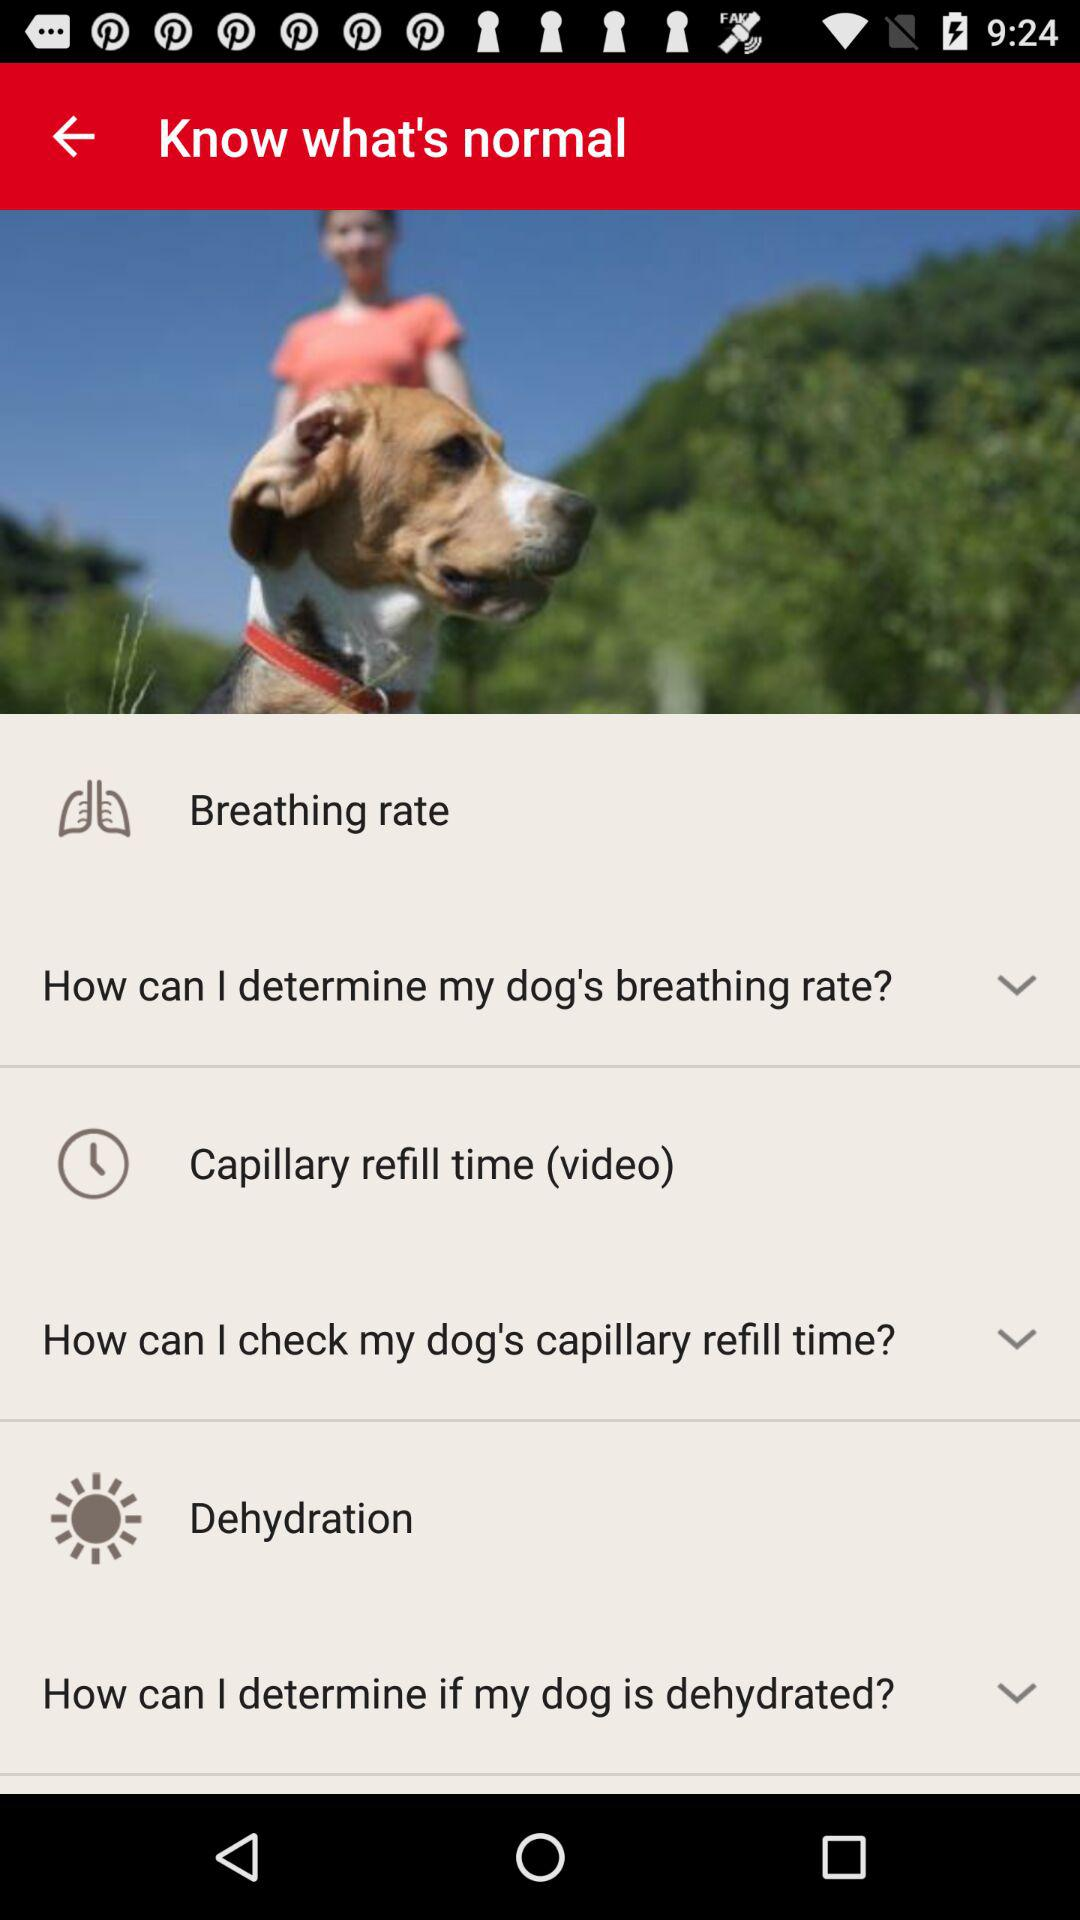How many videos are in the how to know what's normal section?
Answer the question using a single word or phrase. 3 